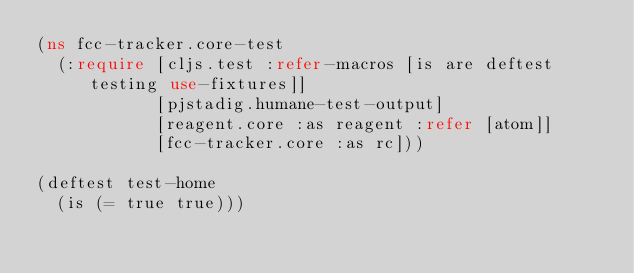Convert code to text. <code><loc_0><loc_0><loc_500><loc_500><_Clojure_>(ns fcc-tracker.core-test
  (:require [cljs.test :refer-macros [is are deftest testing use-fixtures]]
            [pjstadig.humane-test-output]
            [reagent.core :as reagent :refer [atom]]
            [fcc-tracker.core :as rc]))

(deftest test-home
  (is (= true true)))

</code> 